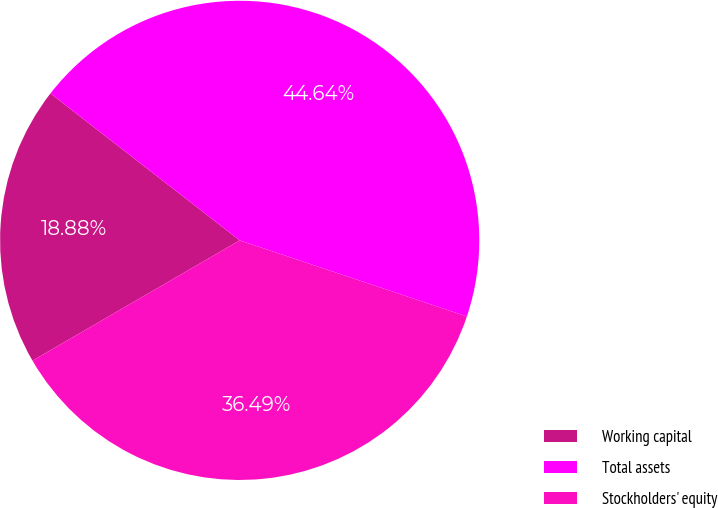Convert chart to OTSL. <chart><loc_0><loc_0><loc_500><loc_500><pie_chart><fcel>Working capital<fcel>Total assets<fcel>Stockholders' equity<nl><fcel>18.88%<fcel>44.64%<fcel>36.49%<nl></chart> 